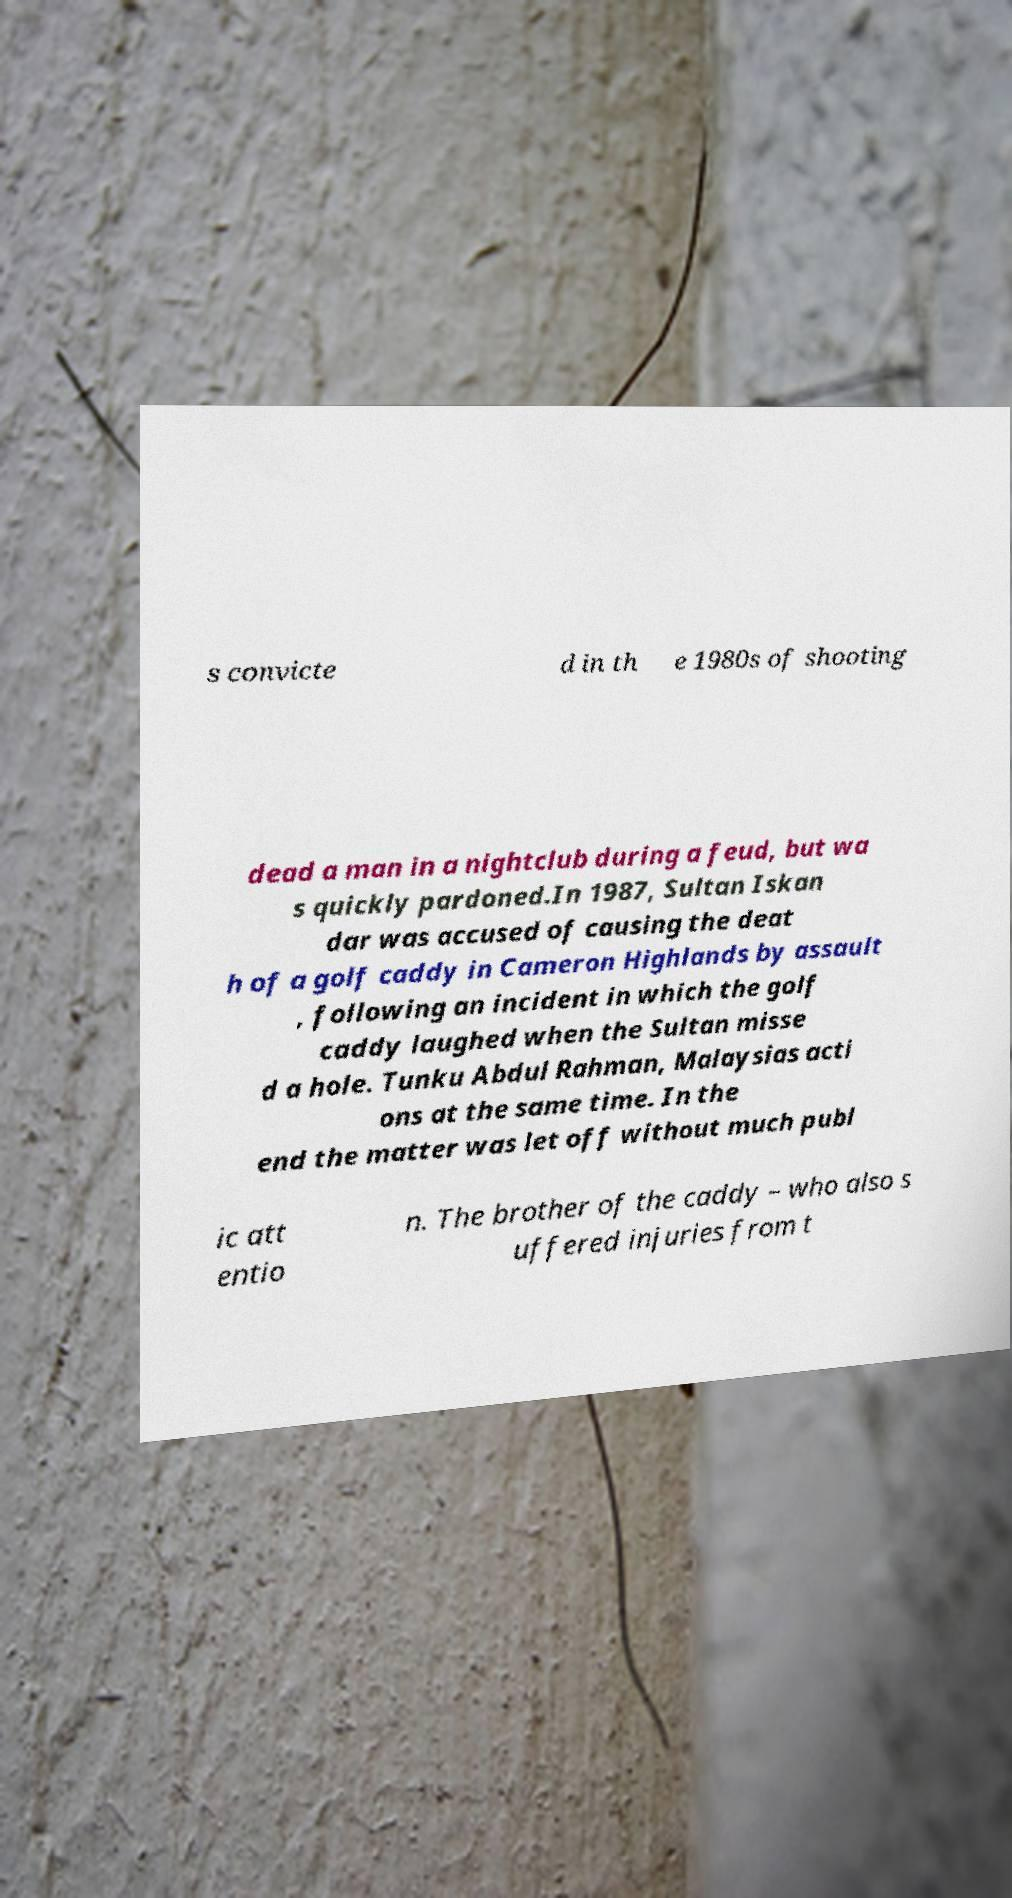Please identify and transcribe the text found in this image. s convicte d in th e 1980s of shooting dead a man in a nightclub during a feud, but wa s quickly pardoned.In 1987, Sultan Iskan dar was accused of causing the deat h of a golf caddy in Cameron Highlands by assault , following an incident in which the golf caddy laughed when the Sultan misse d a hole. Tunku Abdul Rahman, Malaysias acti ons at the same time. In the end the matter was let off without much publ ic att entio n. The brother of the caddy – who also s uffered injuries from t 